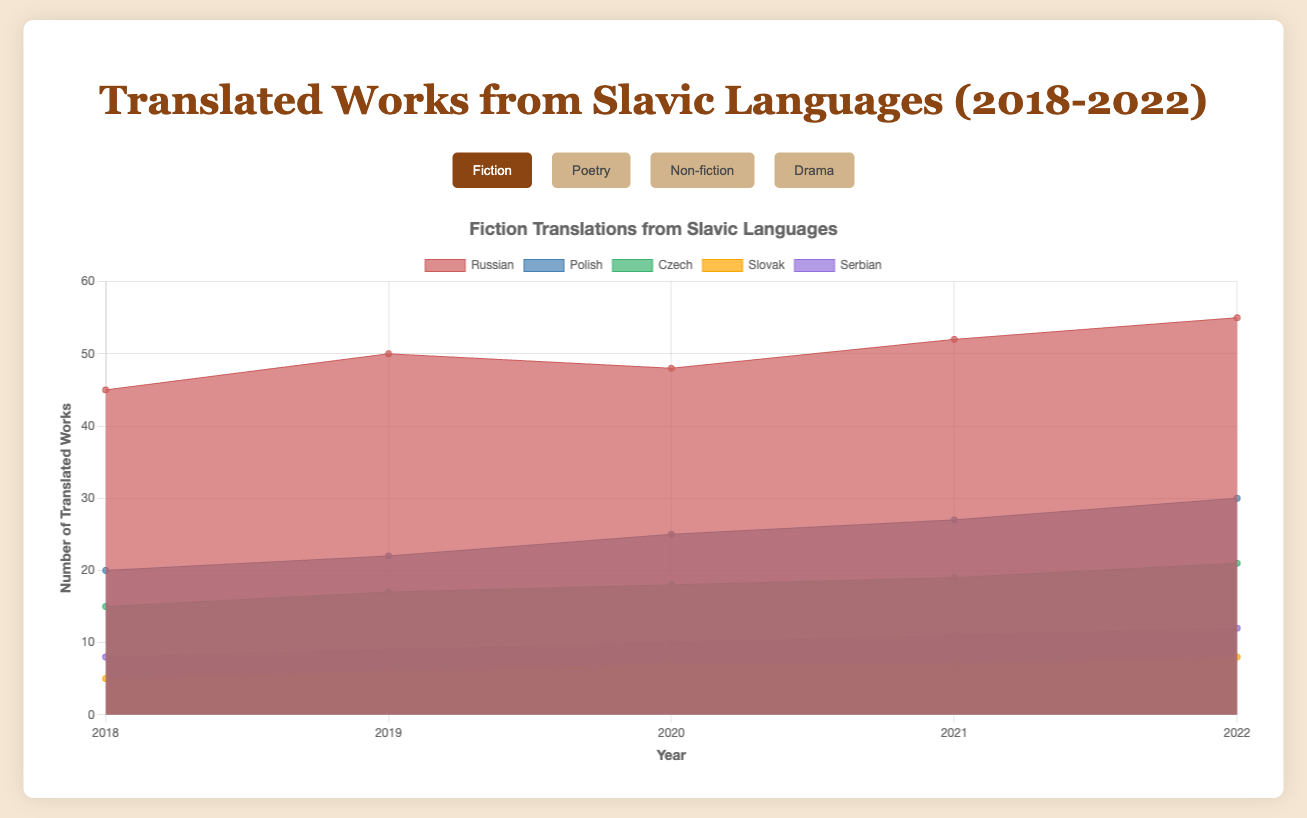What's the title of the chart? The title is displayed at the top of the chart.
Answer: Translated Works from Slavic Languages (2018-2022) How many genres are displayed in the chart? The genres are selectable buttons above the chart. Count the buttons.
Answer: 4 From which genre did Russian translations have the highest number in 2022? Switch to the "Non-fiction" genre and look at the value for the year 2022. Russian has the highest count.
Answer: Non-fiction How many Fiction works were translated from Czech in total from 2018 to 2022? Sum the values for Fiction Czech for the years 2018 to 2022: 15 + 17 + 18 + 19 + 21.
Answer: 90 Which Slavic language had the smallest number of Drama translations in 2018? Look at the Drama translations for 2018 across languages and find the smallest value.
Answer: Slovak Comparing Polish translations, which genre had the highest increase from 2018 to 2022? Subtract the Polish 2018 values from the 2022 values for each genre and identify the largest difference: Poetry (18-12=6), Fiction (30-20=10), Non-fiction (26-18=8), Drama (15-10=5). Fiction has the highest increase.
Answer: Fiction What is the average annual number of Poetry translations from Serbian from 2018 to 2022? Sum the values of Serbian Poetry from 2018 to 2022 and divide by the number of years (5): (6 + 7 + 8 + 9 + 10) / 5 = 8.
Answer: 8 Which genre has the least variance in the number of translations from Polish between 2018 to 2022? Calculate the range (highest minus lowest value) for each genre for Polish: Fiction (30-20=10), Poetry (18-12=6), Non-fiction (26-18=8), Drama (15-10=5). Drama has the least variance.
Answer: Drama Between 2020 and 2021, which language had the largest drop in number of Fiction translations? Subtract the 2021 values from the 2020 values for Fiction translations: Russian (52-48=4 increase), Polish (27-25=2 increase), Czech (19-18=1 increase), Slovak (7-7=0 same), Serbian (11-10=1 increase). There is no drop; all values increased or stayed the same.
Answer: No drop How did the number of translated Non-fiction works in Russian change from 2018 to 2022? Compare the values for 2018 and 2022 for Russian Non-fiction: 65 - 50 = 15 increase.
Answer: Increased by 15 